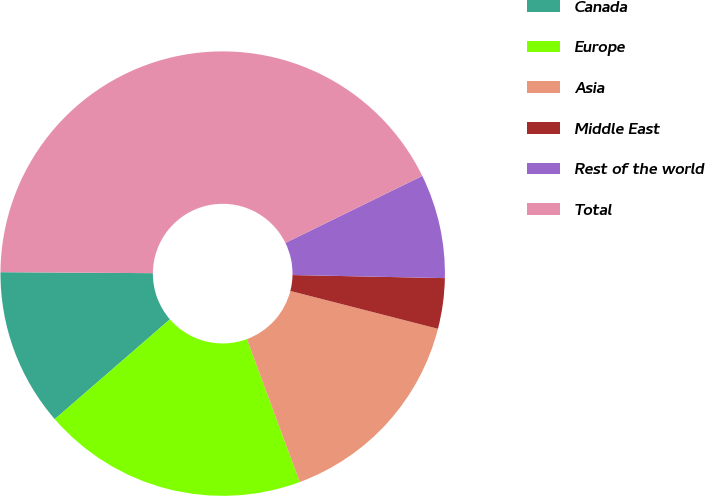<chart> <loc_0><loc_0><loc_500><loc_500><pie_chart><fcel>Canada<fcel>Europe<fcel>Asia<fcel>Middle East<fcel>Rest of the world<fcel>Total<nl><fcel>11.47%<fcel>19.27%<fcel>15.37%<fcel>3.67%<fcel>7.57%<fcel>42.65%<nl></chart> 